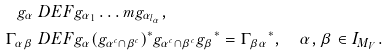<formula> <loc_0><loc_0><loc_500><loc_500>g _ { \alpha } & \ D E F g _ { \alpha _ { 1 } } \dots m g _ { \alpha _ { l _ { \alpha } } } , \\ \Gamma _ { \alpha \beta } & \ D E F g _ { \alpha } ( { g _ { \alpha ^ { c } \cap \beta ^ { c } } } ) ^ { * } g _ { \alpha ^ { c } \cap \beta ^ { c } } { g _ { \beta } } ^ { * } = { \Gamma _ { \beta \alpha } } ^ { * } , \quad \alpha , \beta \in I _ { M _ { V } } .</formula> 